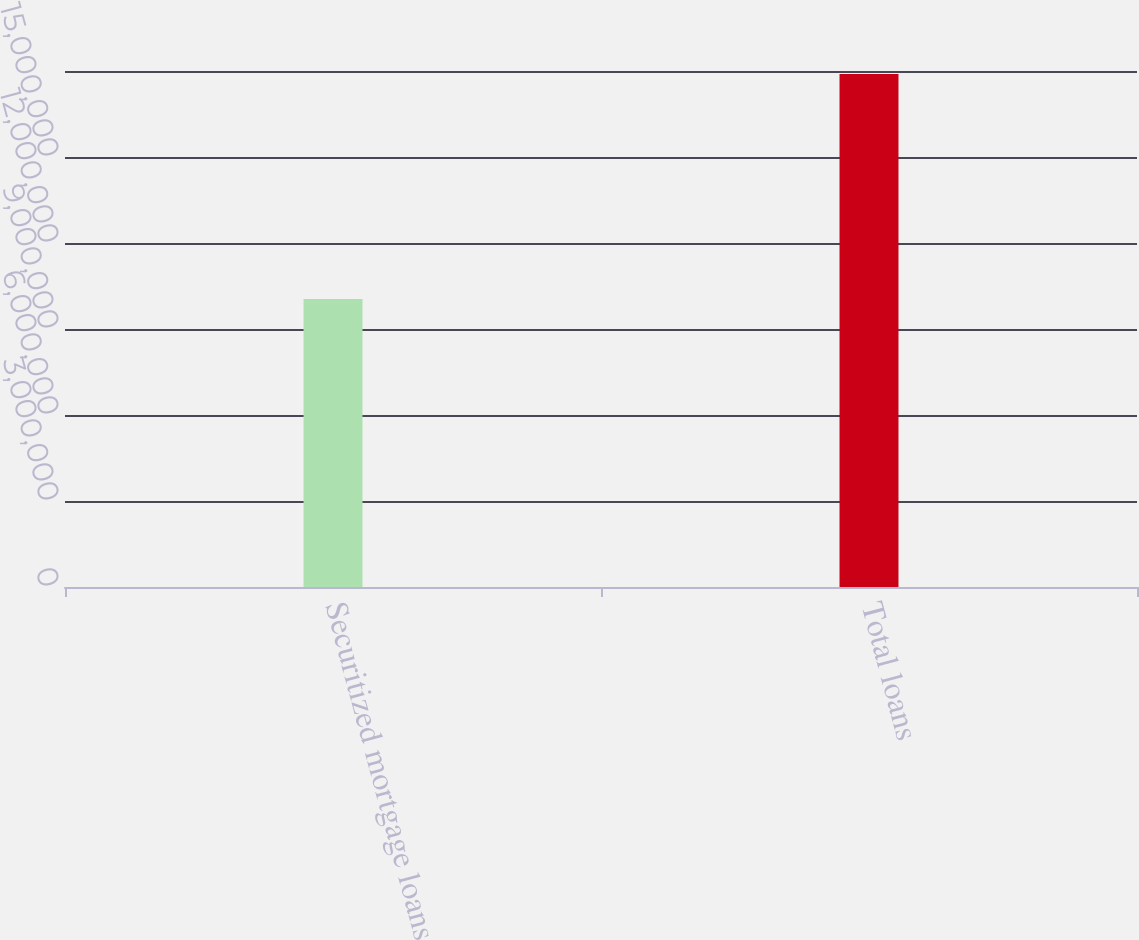Convert chart. <chart><loc_0><loc_0><loc_500><loc_500><bar_chart><fcel>Securitized mortgage loans<fcel>Total loans<nl><fcel>1.0046e+07<fcel>1.78919e+07<nl></chart> 